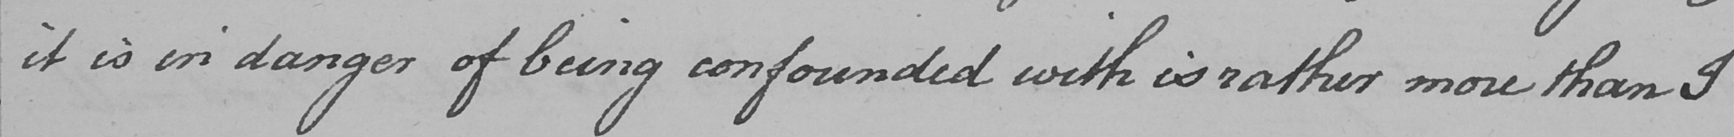What is written in this line of handwriting? it is in danger of being confounded with is rather more than I 